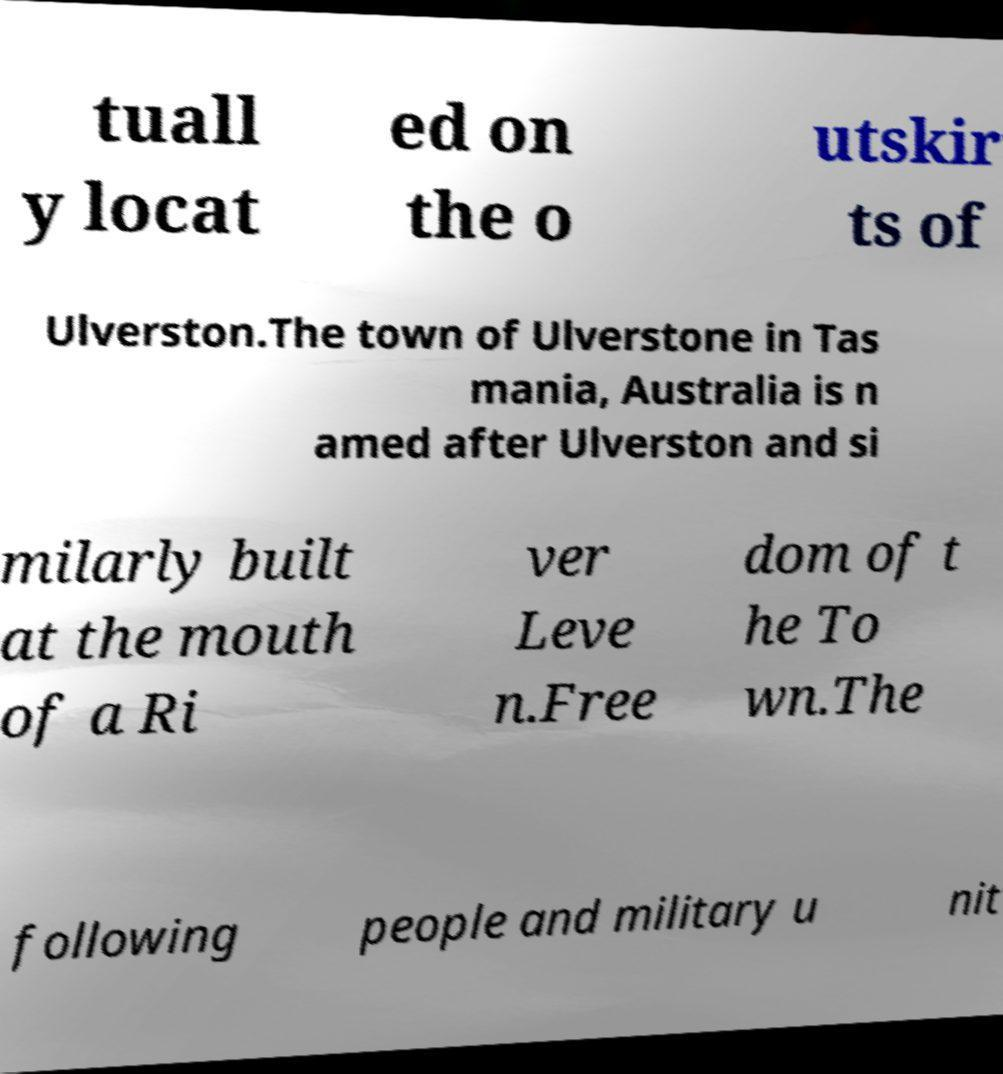For documentation purposes, I need the text within this image transcribed. Could you provide that? tuall y locat ed on the o utskir ts of Ulverston.The town of Ulverstone in Tas mania, Australia is n amed after Ulverston and si milarly built at the mouth of a Ri ver Leve n.Free dom of t he To wn.The following people and military u nit 